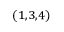Convert formula to latex. <formula><loc_0><loc_0><loc_500><loc_500>^ { ( 1 , 3 , 4 ) }</formula> 